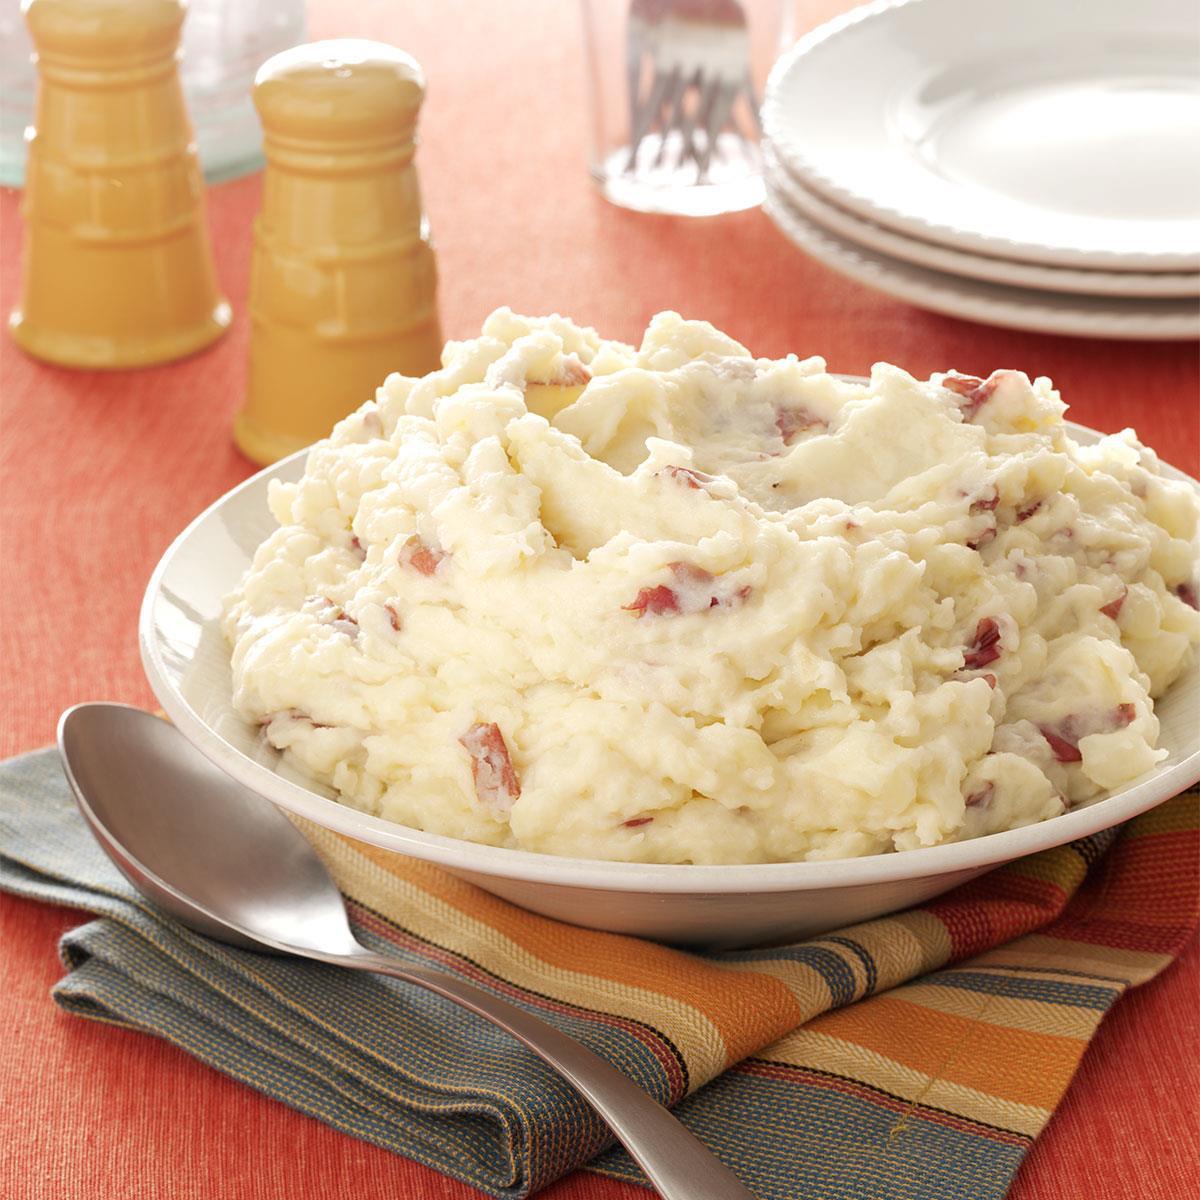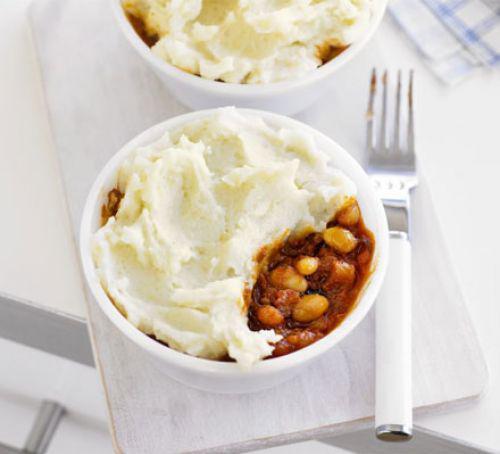The first image is the image on the left, the second image is the image on the right. Examine the images to the left and right. Is the description "an eating utensil can be seen in the image on the right" accurate? Answer yes or no. Yes. The first image is the image on the left, the second image is the image on the right. For the images displayed, is the sentence "There is one spoon sitting next to a bowl of food." factually correct? Answer yes or no. Yes. 